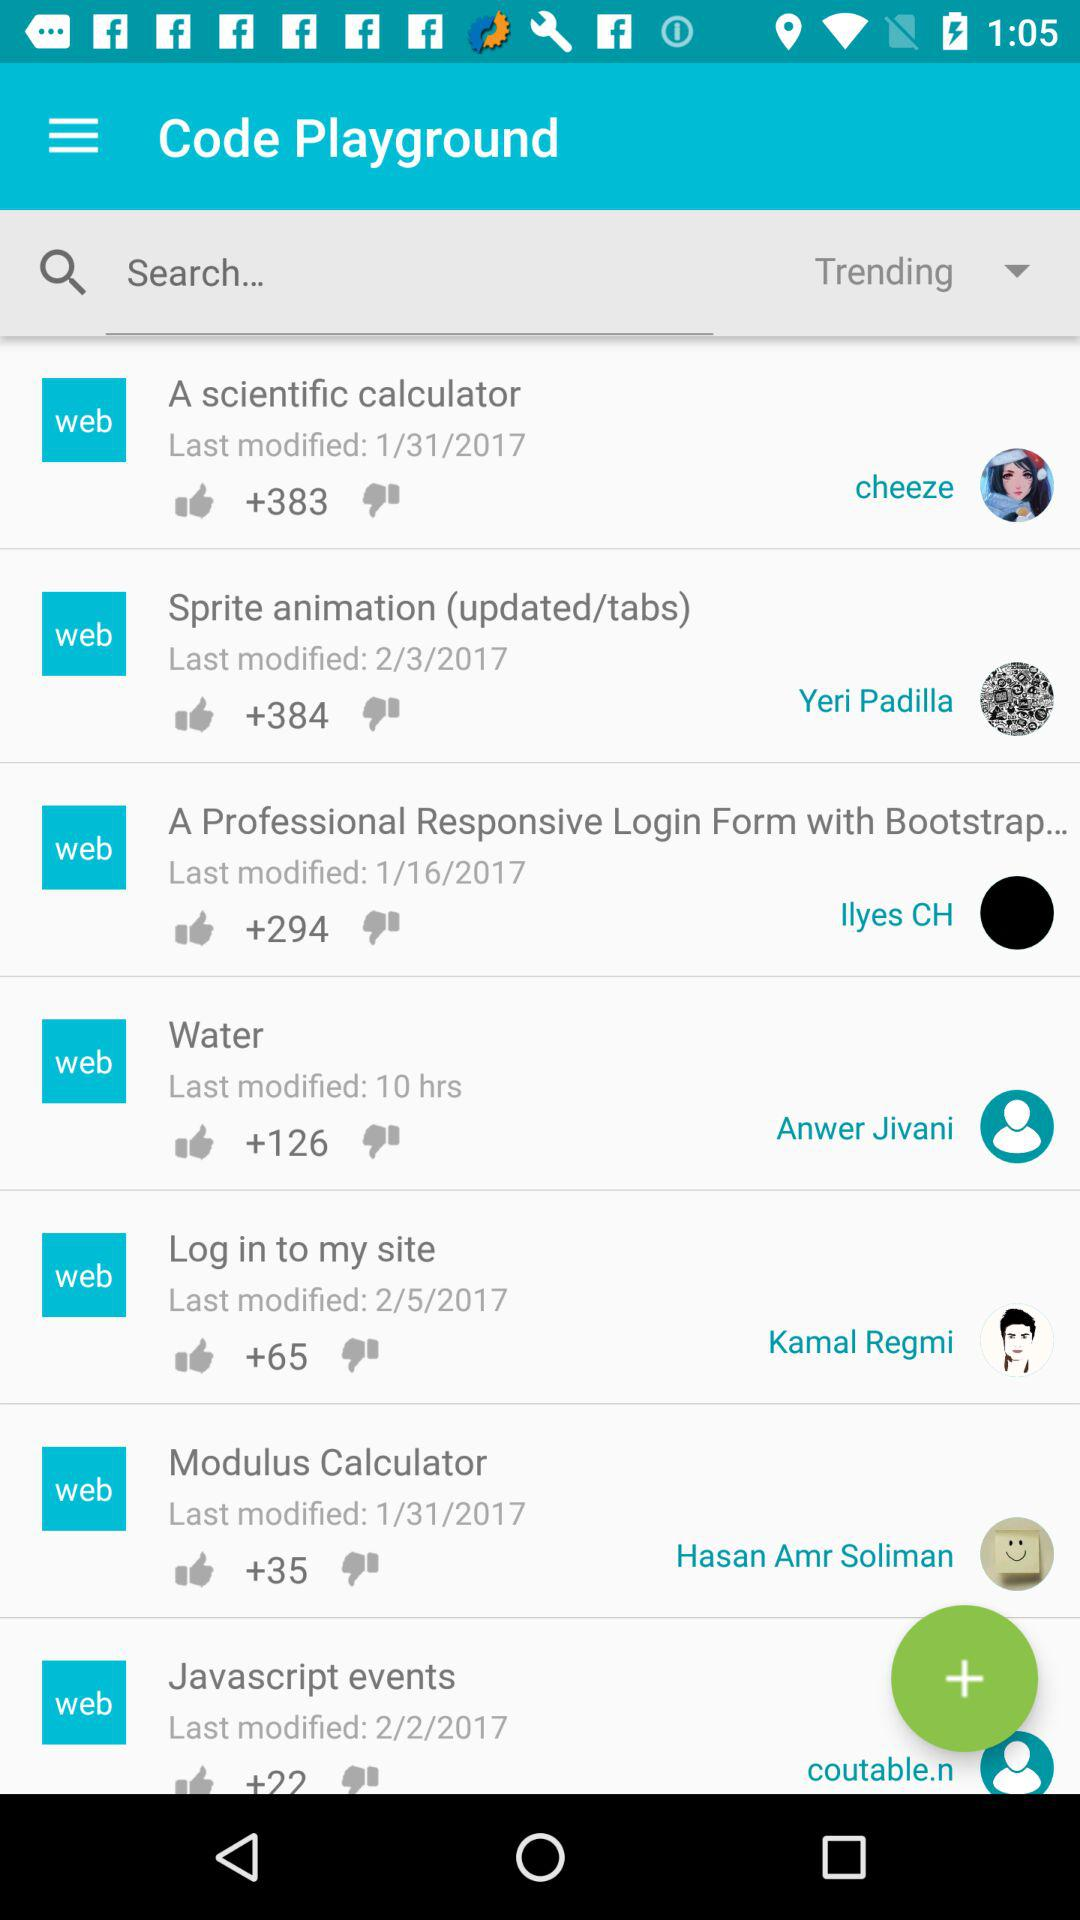When were javascript events last modified? Javascript events were last modified on February 2, 2017. 